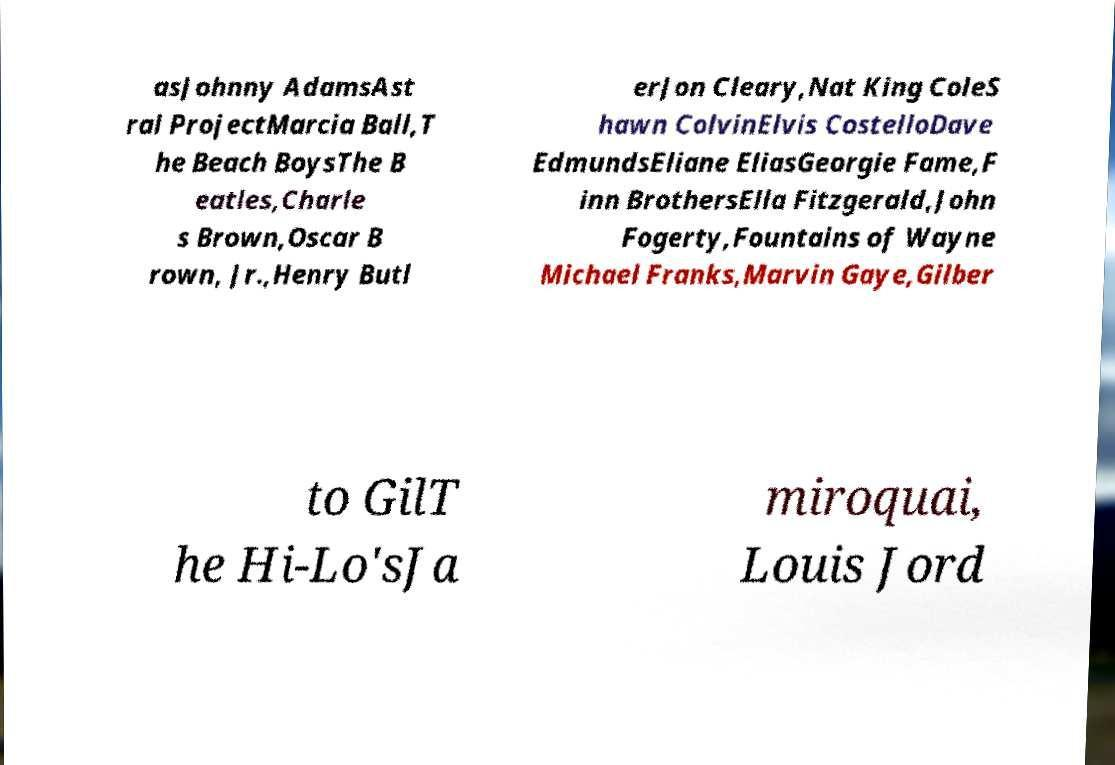Please identify and transcribe the text found in this image. asJohnny AdamsAst ral ProjectMarcia Ball,T he Beach BoysThe B eatles,Charle s Brown,Oscar B rown, Jr.,Henry Butl erJon Cleary,Nat King ColeS hawn ColvinElvis CostelloDave EdmundsEliane EliasGeorgie Fame,F inn BrothersElla Fitzgerald,John Fogerty,Fountains of Wayne Michael Franks,Marvin Gaye,Gilber to GilT he Hi-Lo'sJa miroquai, Louis Jord 